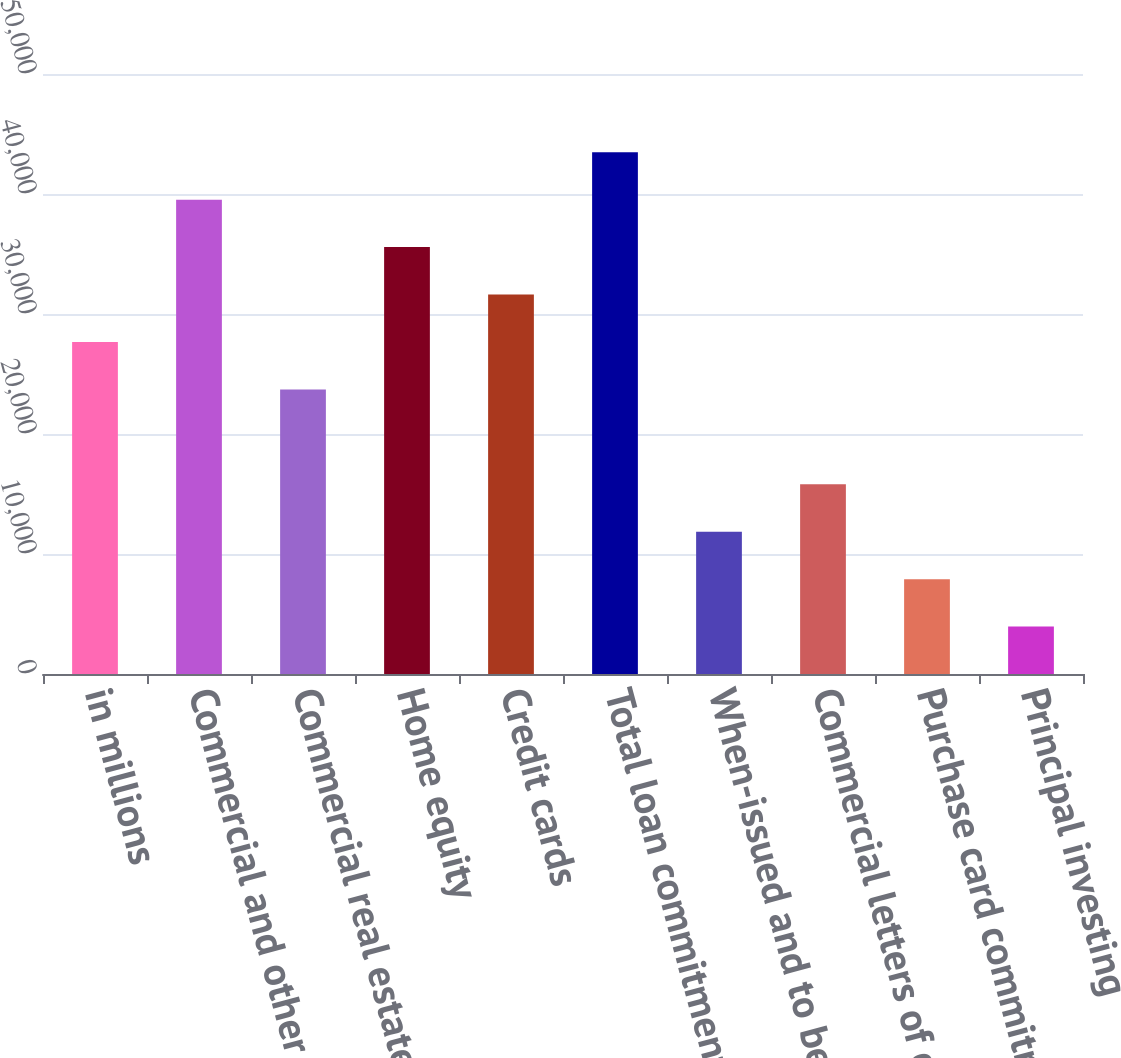Convert chart to OTSL. <chart><loc_0><loc_0><loc_500><loc_500><bar_chart><fcel>in millions<fcel>Commercial and other<fcel>Commercial real estate and<fcel>Home equity<fcel>Credit cards<fcel>Total loan commitments<fcel>When-issued and to be<fcel>Commercial letters of credit<fcel>Purchase card commitments<fcel>Principal investing<nl><fcel>27668.5<fcel>39526<fcel>23716<fcel>35573.5<fcel>31621<fcel>43478.5<fcel>11858.5<fcel>15811<fcel>7906<fcel>3953.5<nl></chart> 